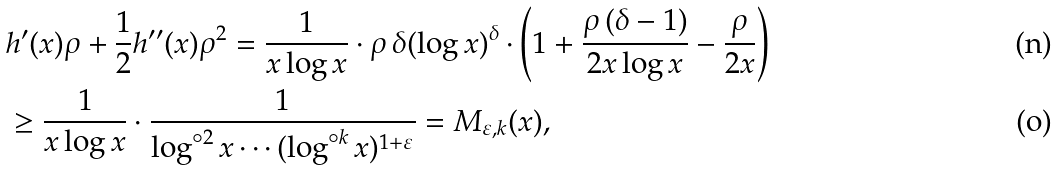Convert formula to latex. <formula><loc_0><loc_0><loc_500><loc_500>& h ^ { \prime } ( x ) \rho + \frac { 1 } { 2 } h ^ { \prime \prime } ( x ) \rho ^ { 2 } = \frac { 1 } { x \log x } \cdot \rho \, \delta ( \log x ) ^ { \delta } \cdot \left ( 1 + \frac { \rho \, ( \delta - 1 ) } { 2 x \log x } - \frac { \rho } { 2 x } \right ) \\ & \geq \frac { 1 } { x \log x } \cdot \frac { 1 } { \log ^ { \circ 2 } x \cdots ( \log ^ { \circ k } x ) ^ { 1 + \varepsilon } } = M _ { \varepsilon , k } ( x ) ,</formula> 